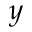Convert formula to latex. <formula><loc_0><loc_0><loc_500><loc_500>y</formula> 